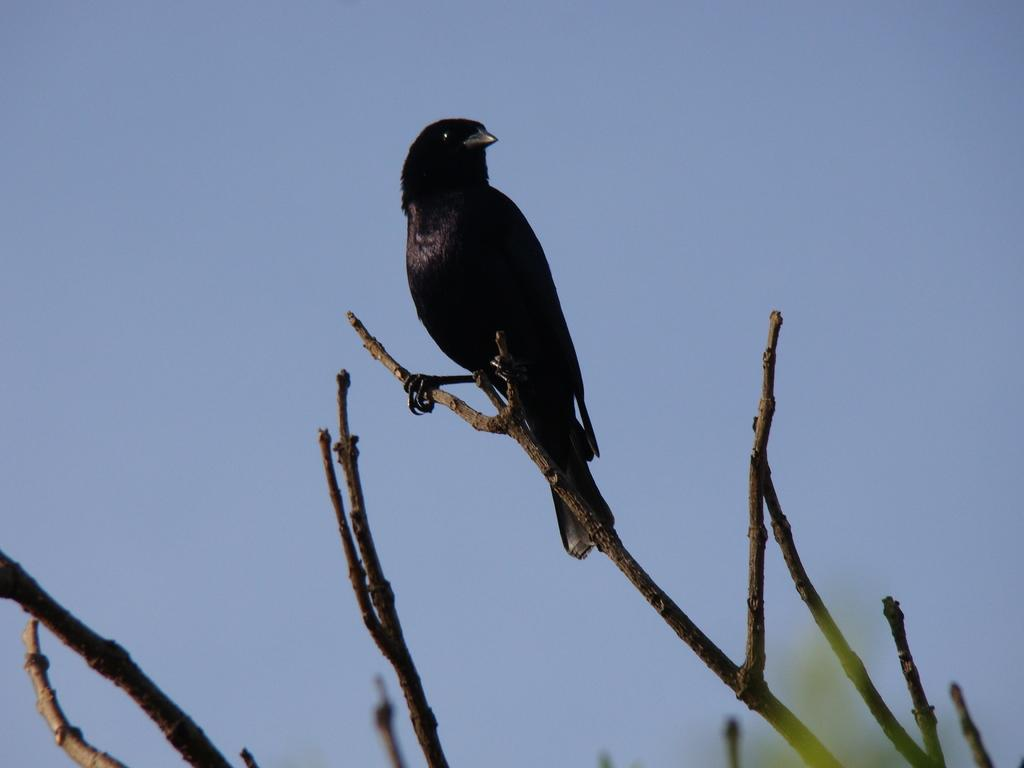What type of animal can be seen in the image? There is a bird in the image. Where is the bird located? The bird is on a stem in the image. Are there any other stems visible in the image? Yes, there are other stems visible in the image. What can be seen in the background of the image? The sky is visible in the background of the image. What type of poison is the bird using to attack the quill in the image? There is no poison or quill present in the image; it features a bird on a stem with other stems visible in the background. 